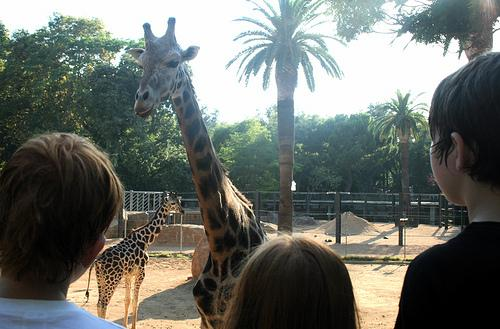How tall is the average newborn giraffe? 6 feet 